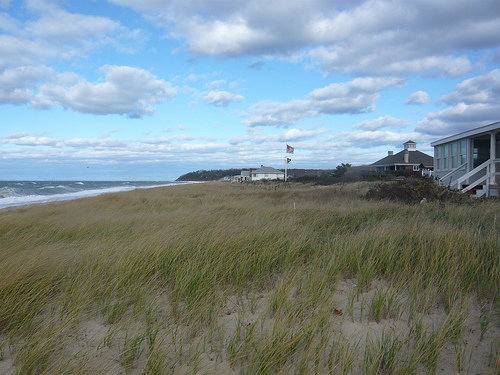<image>
Can you confirm if the cloud is in the sky? Yes. The cloud is contained within or inside the sky, showing a containment relationship. 